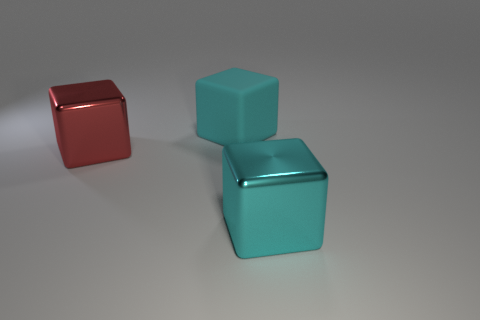There is a cube in front of the large red cube; is its color the same as the large rubber block left of the big cyan metal thing?
Keep it short and to the point. Yes. There is another shiny thing that is the same shape as the red metal thing; what size is it?
Your answer should be very brief. Large. Is the material of the cube that is right of the big matte cube the same as the cyan cube behind the red shiny cube?
Provide a short and direct response. No. What number of metal objects are red objects or tiny brown spheres?
Provide a succinct answer. 1. What is the material of the object that is behind the big red cube that is behind the large cyan object in front of the large red metal block?
Provide a short and direct response. Rubber. There is a cube that is behind the big shiny thing that is behind the big cyan shiny thing; what color is it?
Keep it short and to the point. Cyan. What number of spheres are either large rubber objects or large red objects?
Offer a terse response. 0. There is a cyan thing that is behind the red cube that is in front of the big rubber object; what number of shiny cubes are behind it?
Make the answer very short. 0. What is the size of the shiny block that is the same color as the big matte block?
Your answer should be compact. Large. Are there any other blocks that have the same material as the large red cube?
Keep it short and to the point. Yes. 